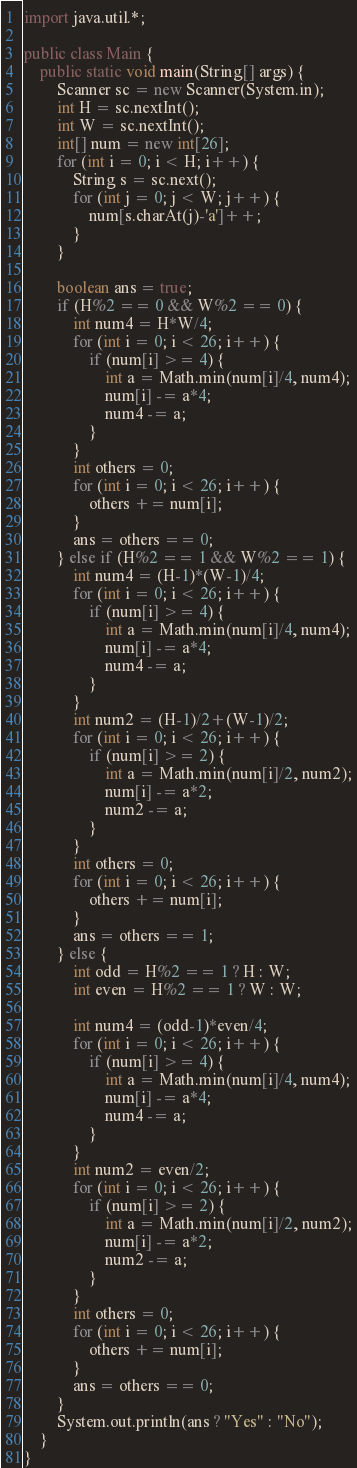<code> <loc_0><loc_0><loc_500><loc_500><_Java_>import java.util.*;
 
public class Main {
    public static void main(String[] args) {
        Scanner sc = new Scanner(System.in);
        int H = sc.nextInt();
        int W = sc.nextInt();
        int[] num = new int[26];
        for (int i = 0; i < H; i++) {
            String s = sc.next();
            for (int j = 0; j < W; j++) {
                num[s.charAt(j)-'a']++;
            }
        }

        boolean ans = true;
        if (H%2 == 0 && W%2 == 0) {
            int num4 = H*W/4;
            for (int i = 0; i < 26; i++) {
                if (num[i] >= 4) {
                    int a = Math.min(num[i]/4, num4);
                    num[i] -= a*4;
                    num4 -= a;
                }
            }
            int others = 0;
            for (int i = 0; i < 26; i++) {
                others += num[i];
            }
            ans = others == 0;
        } else if (H%2 == 1 && W%2 == 1) {
            int num4 = (H-1)*(W-1)/4;
            for (int i = 0; i < 26; i++) {
                if (num[i] >= 4) {
                    int a = Math.min(num[i]/4, num4);
                    num[i] -= a*4;
                    num4 -= a;
                }
            }
            int num2 = (H-1)/2+(W-1)/2;
            for (int i = 0; i < 26; i++) {
                if (num[i] >= 2) {
                    int a = Math.min(num[i]/2, num2);
                    num[i] -= a*2;
                    num2 -= a;
                }
            }
            int others = 0;
            for (int i = 0; i < 26; i++) {
                others += num[i];
            }
            ans = others == 1;
        } else {
            int odd = H%2 == 1 ? H : W;
            int even = H%2 == 1 ? W : W;

            int num4 = (odd-1)*even/4;
            for (int i = 0; i < 26; i++) {
                if (num[i] >= 4) {
                    int a = Math.min(num[i]/4, num4);
                    num[i] -= a*4;
                    num4 -= a;
                }
            }
            int num2 = even/2;
            for (int i = 0; i < 26; i++) {
                if (num[i] >= 2) {
                    int a = Math.min(num[i]/2, num2);
                    num[i] -= a*2;
                    num2 -= a;
                }
            }
            int others = 0;
            for (int i = 0; i < 26; i++) {
                others += num[i];
            }
            ans = others == 0;
        }
        System.out.println(ans ? "Yes" : "No");
    }
}
</code> 